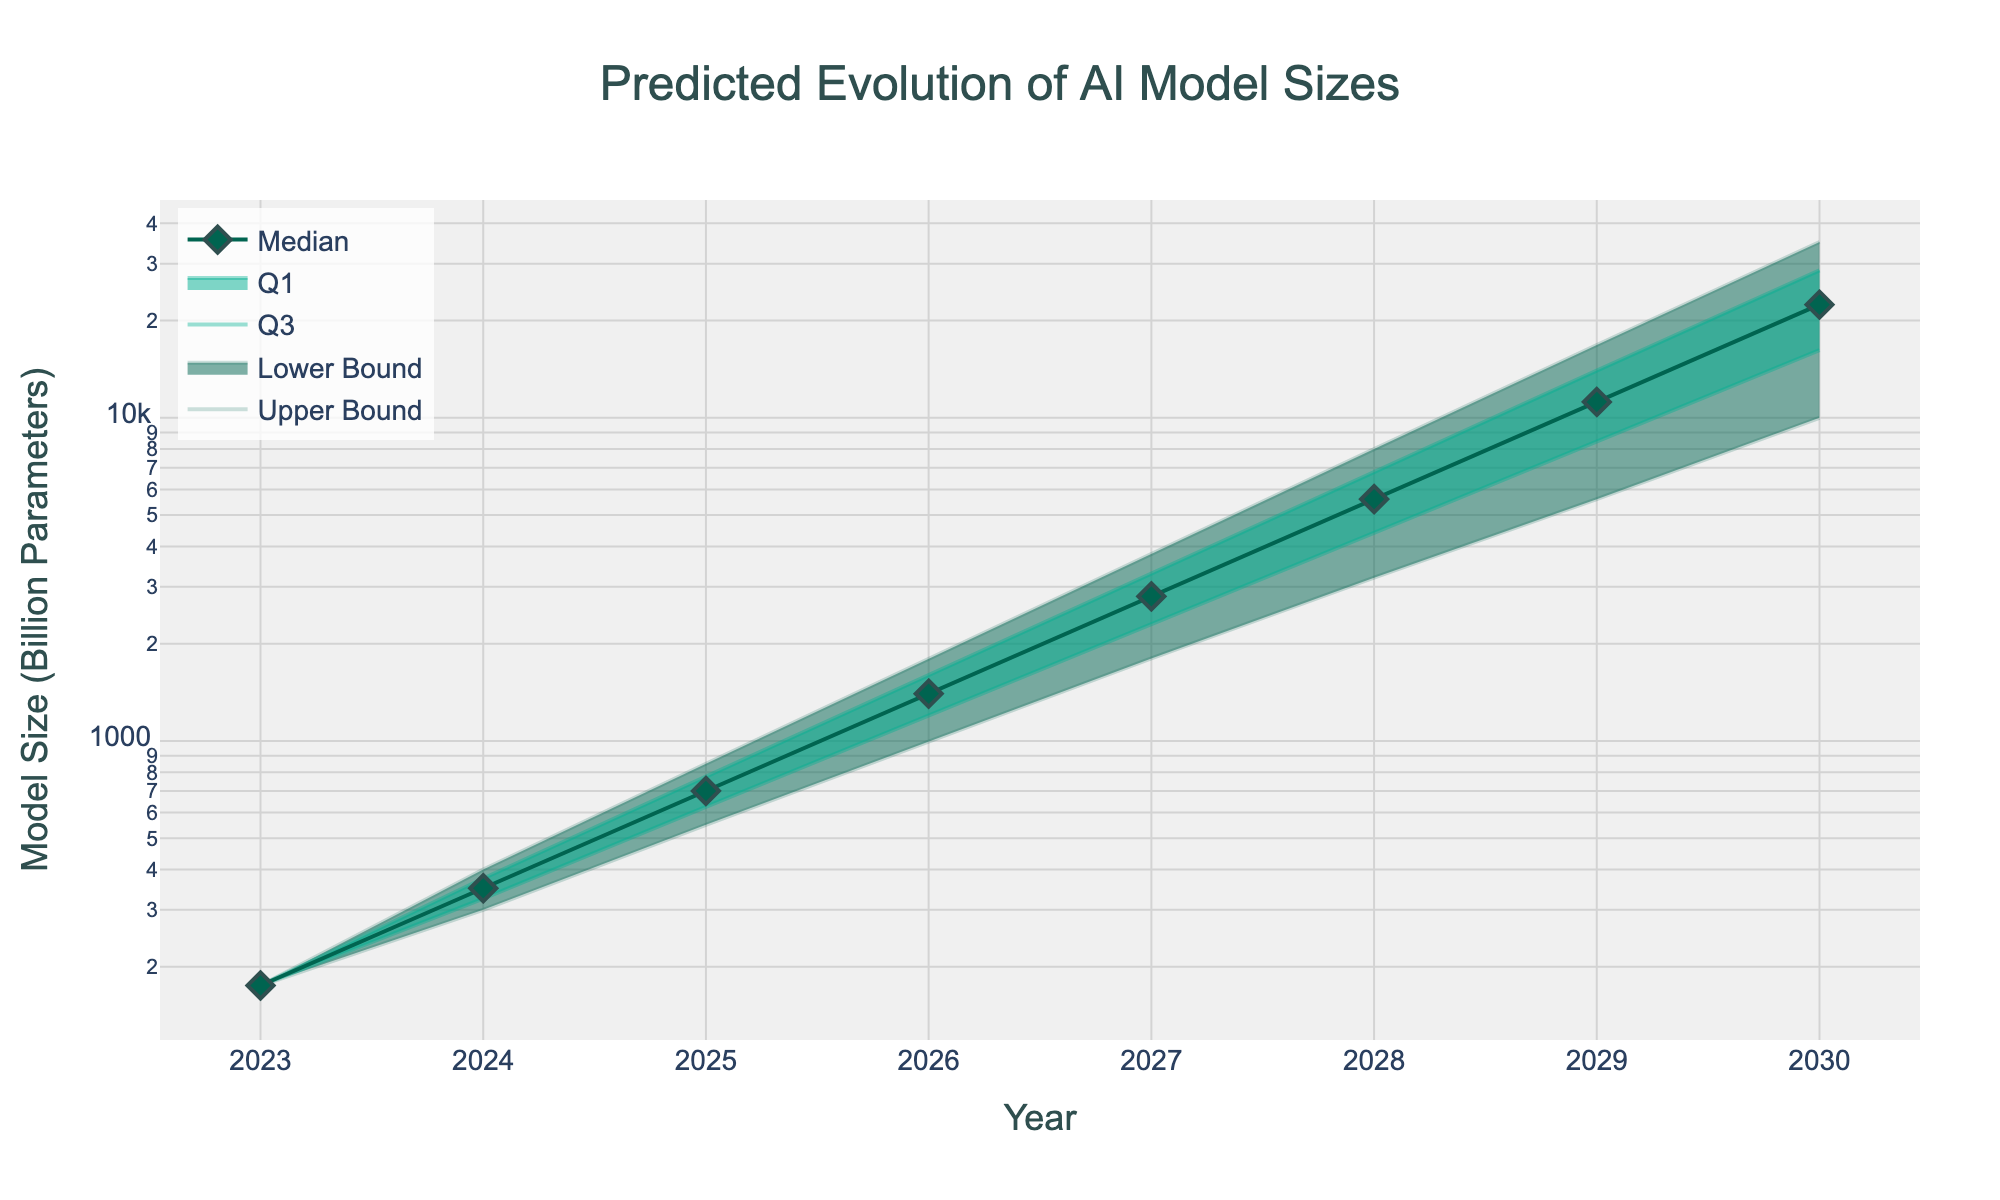What is the title of the figure? The title of a figure is usually located at the top and is explicitly labeled to describe the overall content and purpose of the plot. In this figure, the title reads "Predicted Evolution of AI Model Sizes."
Answer: Predicted Evolution of AI Model Sizes What does the x-axis represent? In the figure, the x-axis is labeled to show what variable is plotted along this axis. Here, it is labeled "Year," indicating that the x-axis represents years from 2023 to 2030.
Answer: Year What is the upper bound of AI model sizes predicted for the year 2026? The upper bound values are represented by the topmost line in the fan chart and specifically marked on the y-axis. For the year 2026, the value is positioned at 1800 billion parameters.
Answer: 1800 billion parameters What is the median AI model size projected for 2029? The median values are depicted by markers along the central line of the fan chart. For the year 2029, the marker indicates 11200 billion parameters.
Answer: 11200 billion parameters How does the predicted median model size change from 2023 to 2028? To determine the change, we compare the median values for 2023 and 2028. The median model size increases from 175 billion parameters in 2023 to 5600 billion parameters in 2028. The difference is 5600 - 175 = 5425 billion parameters.
Answer: Increased by 5425 billion parameters What is the difference between the Q3 and Q1 values in 2030? Both the Q3 and Q1 values are represented by shaded boundaries within the fan chart. For 2030, Q3 is 28600 billion parameters and Q1 is 16200 billion parameters. The difference is 28600 - 16200 = 12400 billion parameters.
Answer: 12400 billion parameters In which year is the predicted AI model size volatility (difference between upper bound and lower bound) the highest? Volatility can be measured by the difference between the upper and lower bounds. Calculating these differences for each year, we find the highest volatility in 2030, where the upper bound is 35000 billion parameters, and the lower bound is 10000 billion parameters, giving a volatility of 35000 - 10000 = 25000 billion parameters.
Answer: 2030 What trends do you observe in the evolution of the AI model sizes over the forecast period? Observing the trends in the median line and bounds, we see a consistent exponential growth in the sizes of AI models over the years. Both the median and the interquartile ranges expand significantly, reflecting increasing computational requirements.
Answer: Exponential growth in model sizes How does the spread between Q1 and Q3 evolve from 2024 to 2029? The spread between Q1 and Q3 can be noted by the distance between the Q3 and Q1 lines on the fan chart. Over the years from 2024 to 2029, the spread grows from 75 billion parameters in 2024 to 5600 billion parameters in 2029, indicating increasing uncertainty and variability in model sizes.
Answer: The spread increases In which year is the predicted AI model size smallest in the given data, and what is its size? By observing the lower bounds in the fan chart, the smallest model size is found in 2023 with a size of 175 billion parameters.
Answer: 2023, 175 billion parameters 